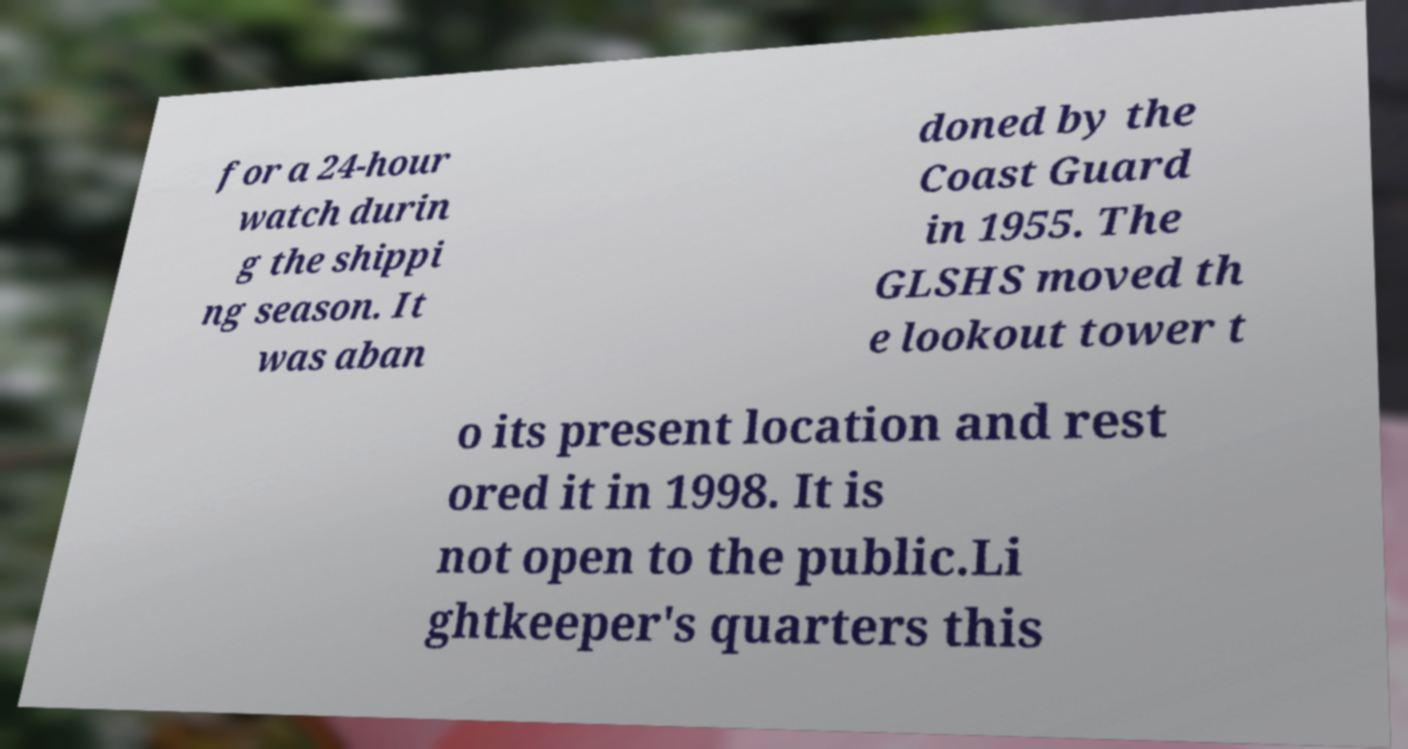Please read and relay the text visible in this image. What does it say? for a 24-hour watch durin g the shippi ng season. It was aban doned by the Coast Guard in 1955. The GLSHS moved th e lookout tower t o its present location and rest ored it in 1998. It is not open to the public.Li ghtkeeper's quarters this 